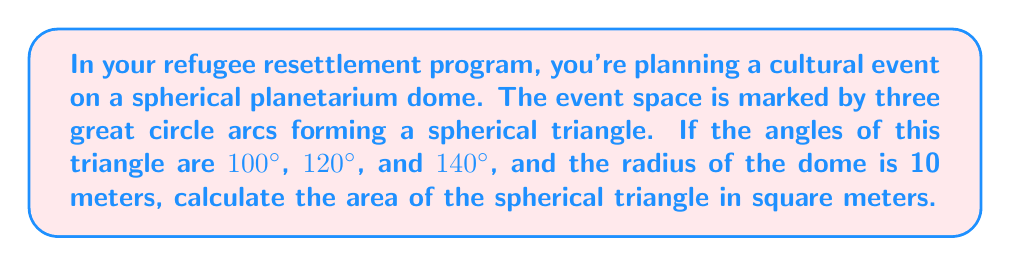What is the answer to this math problem? To solve this problem, we'll use the formula for the area of a spherical triangle:

$$A = (\alpha + \beta + \gamma - \pi)R^2$$

Where:
$A$ is the area of the spherical triangle
$\alpha$, $\beta$, and $\gamma$ are the angles of the spherical triangle in radians
$R$ is the radius of the sphere
$\pi$ is pi (approximately 3.14159)

Steps:
1) Convert the given angles from degrees to radians:
   $100° = \frac{100\pi}{180} \approx 1.7453$ radians
   $120° = \frac{120\pi}{180} \approx 2.0944$ radians
   $140° = \frac{140\pi}{180} \approx 2.4435$ radians

2) Sum the angles:
   $\alpha + \beta + \gamma = 1.7453 + 2.0944 + 2.4435 = 6.2832$ radians

3) Subtract $\pi$ from the sum:
   $6.2832 - \pi \approx 3.1416$

4) Multiply by $R^2$ (given $R = 10$ meters):
   $A = 3.1416 \times 10^2 = 314.16$ square meters

Therefore, the area of the spherical triangle is approximately 314.16 square meters.
Answer: 314.16 m² 